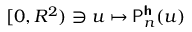<formula> <loc_0><loc_0><loc_500><loc_500>[ 0 , R ^ { 2 } ) \ni u \mapsto P _ { n } ^ { h } ( u )</formula> 